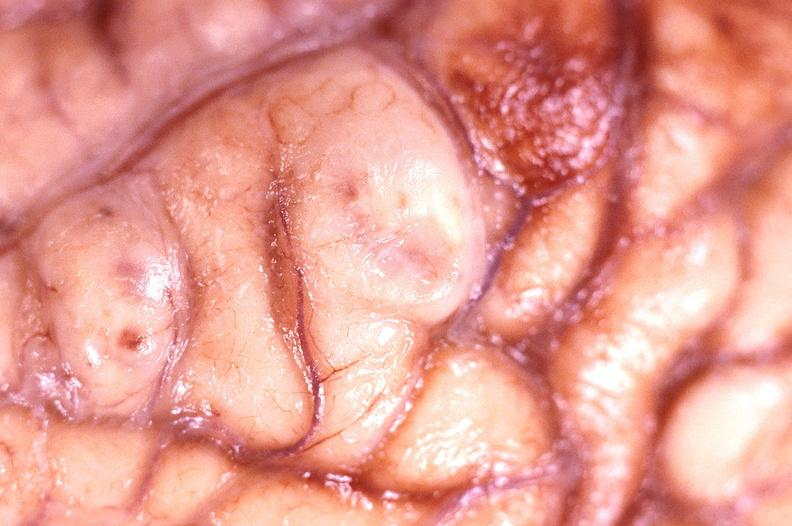s nervous present?
Answer the question using a single word or phrase. Yes 